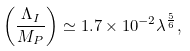<formula> <loc_0><loc_0><loc_500><loc_500>\left ( \frac { \Lambda _ { I } } { M _ { P } } \right ) \simeq 1 . 7 \times 1 0 ^ { - 2 } \lambda ^ { \frac { 5 } { 6 } } ,</formula> 